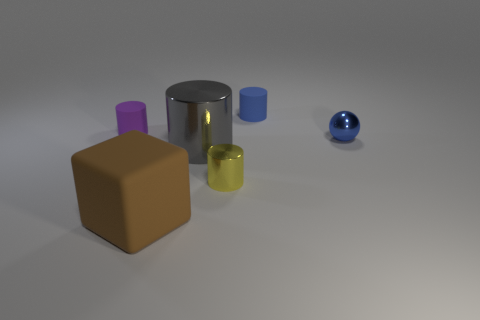How big is the metallic cylinder behind the tiny shiny thing to the left of the cylinder that is behind the tiny purple matte cylinder?
Make the answer very short. Large. The matte thing that is behind the big gray metallic thing and on the left side of the tiny yellow metallic cylinder is what color?
Make the answer very short. Purple. There is a yellow cylinder; is it the same size as the blue object on the left side of the blue metal ball?
Provide a short and direct response. Yes. Is there any other thing that is the same shape as the blue rubber object?
Keep it short and to the point. Yes. What is the color of the other metal thing that is the same shape as the small yellow object?
Keep it short and to the point. Gray. Is the brown rubber block the same size as the metal ball?
Your response must be concise. No. How many other things are there of the same size as the blue ball?
Make the answer very short. 3. How many objects are large objects behind the large rubber object or matte objects that are behind the small blue ball?
Provide a succinct answer. 3. What is the shape of the blue object that is the same size as the metallic sphere?
Provide a succinct answer. Cylinder. There is a brown thing that is the same material as the tiny purple object; what size is it?
Give a very brief answer. Large. 